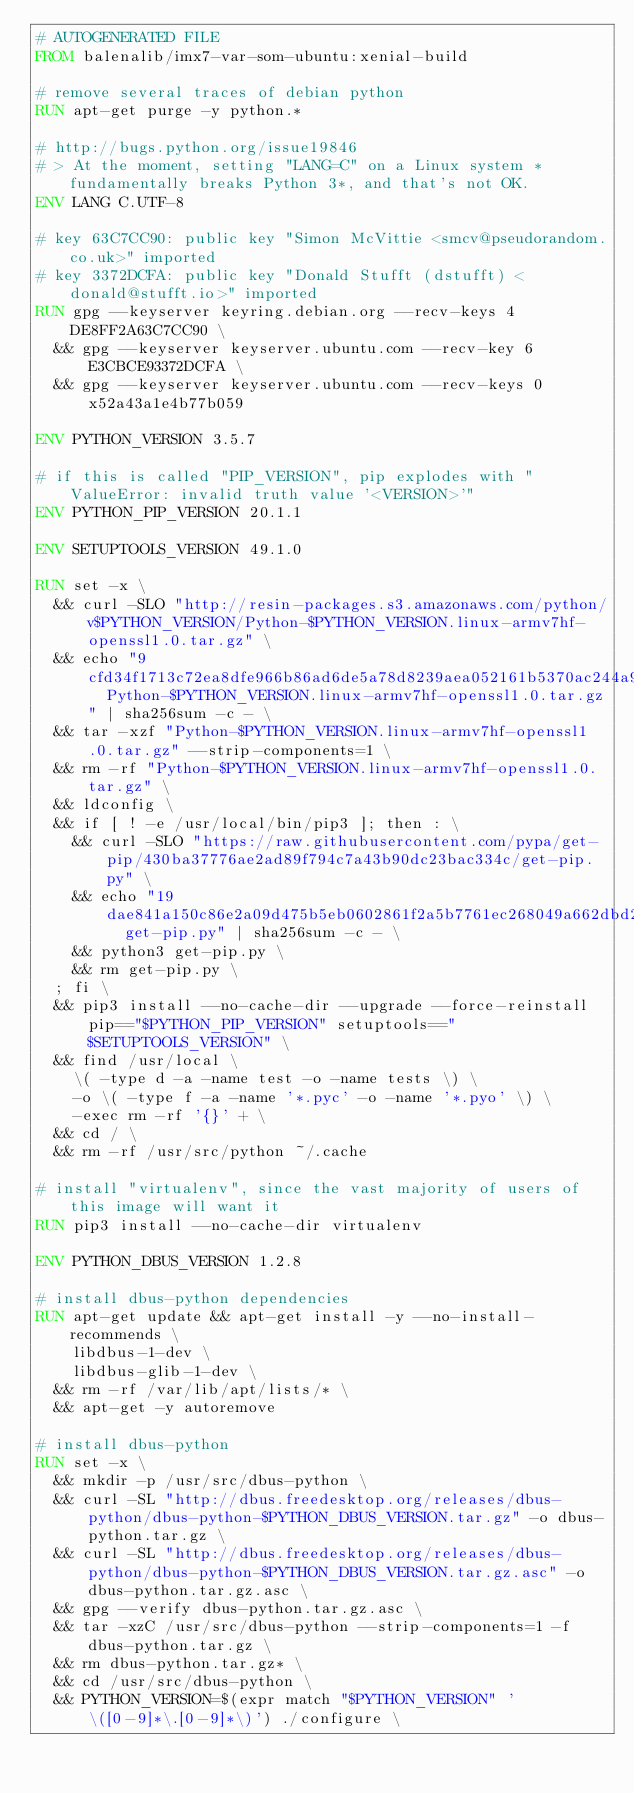Convert code to text. <code><loc_0><loc_0><loc_500><loc_500><_Dockerfile_># AUTOGENERATED FILE
FROM balenalib/imx7-var-som-ubuntu:xenial-build

# remove several traces of debian python
RUN apt-get purge -y python.*

# http://bugs.python.org/issue19846
# > At the moment, setting "LANG=C" on a Linux system *fundamentally breaks Python 3*, and that's not OK.
ENV LANG C.UTF-8

# key 63C7CC90: public key "Simon McVittie <smcv@pseudorandom.co.uk>" imported
# key 3372DCFA: public key "Donald Stufft (dstufft) <donald@stufft.io>" imported
RUN gpg --keyserver keyring.debian.org --recv-keys 4DE8FF2A63C7CC90 \
	&& gpg --keyserver keyserver.ubuntu.com --recv-key 6E3CBCE93372DCFA \
	&& gpg --keyserver keyserver.ubuntu.com --recv-keys 0x52a43a1e4b77b059

ENV PYTHON_VERSION 3.5.7

# if this is called "PIP_VERSION", pip explodes with "ValueError: invalid truth value '<VERSION>'"
ENV PYTHON_PIP_VERSION 20.1.1

ENV SETUPTOOLS_VERSION 49.1.0

RUN set -x \
	&& curl -SLO "http://resin-packages.s3.amazonaws.com/python/v$PYTHON_VERSION/Python-$PYTHON_VERSION.linux-armv7hf-openssl1.0.tar.gz" \
	&& echo "9cfd34f1713c72ea8dfe966b86ad6de5a78d8239aea052161b5370ac244a94b9  Python-$PYTHON_VERSION.linux-armv7hf-openssl1.0.tar.gz" | sha256sum -c - \
	&& tar -xzf "Python-$PYTHON_VERSION.linux-armv7hf-openssl1.0.tar.gz" --strip-components=1 \
	&& rm -rf "Python-$PYTHON_VERSION.linux-armv7hf-openssl1.0.tar.gz" \
	&& ldconfig \
	&& if [ ! -e /usr/local/bin/pip3 ]; then : \
		&& curl -SLO "https://raw.githubusercontent.com/pypa/get-pip/430ba37776ae2ad89f794c7a43b90dc23bac334c/get-pip.py" \
		&& echo "19dae841a150c86e2a09d475b5eb0602861f2a5b7761ec268049a662dbd2bd0c  get-pip.py" | sha256sum -c - \
		&& python3 get-pip.py \
		&& rm get-pip.py \
	; fi \
	&& pip3 install --no-cache-dir --upgrade --force-reinstall pip=="$PYTHON_PIP_VERSION" setuptools=="$SETUPTOOLS_VERSION" \
	&& find /usr/local \
		\( -type d -a -name test -o -name tests \) \
		-o \( -type f -a -name '*.pyc' -o -name '*.pyo' \) \
		-exec rm -rf '{}' + \
	&& cd / \
	&& rm -rf /usr/src/python ~/.cache

# install "virtualenv", since the vast majority of users of this image will want it
RUN pip3 install --no-cache-dir virtualenv

ENV PYTHON_DBUS_VERSION 1.2.8

# install dbus-python dependencies 
RUN apt-get update && apt-get install -y --no-install-recommends \
		libdbus-1-dev \
		libdbus-glib-1-dev \
	&& rm -rf /var/lib/apt/lists/* \
	&& apt-get -y autoremove

# install dbus-python
RUN set -x \
	&& mkdir -p /usr/src/dbus-python \
	&& curl -SL "http://dbus.freedesktop.org/releases/dbus-python/dbus-python-$PYTHON_DBUS_VERSION.tar.gz" -o dbus-python.tar.gz \
	&& curl -SL "http://dbus.freedesktop.org/releases/dbus-python/dbus-python-$PYTHON_DBUS_VERSION.tar.gz.asc" -o dbus-python.tar.gz.asc \
	&& gpg --verify dbus-python.tar.gz.asc \
	&& tar -xzC /usr/src/dbus-python --strip-components=1 -f dbus-python.tar.gz \
	&& rm dbus-python.tar.gz* \
	&& cd /usr/src/dbus-python \
	&& PYTHON_VERSION=$(expr match "$PYTHON_VERSION" '\([0-9]*\.[0-9]*\)') ./configure \</code> 